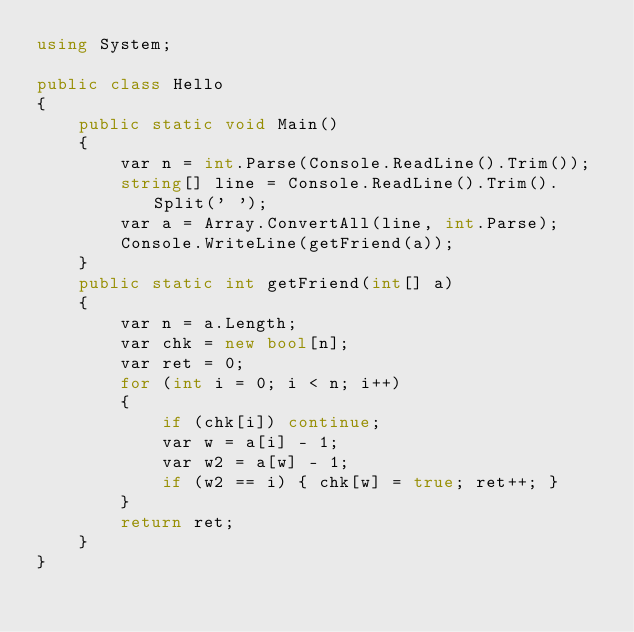Convert code to text. <code><loc_0><loc_0><loc_500><loc_500><_C#_>using System;

public class Hello
{
    public static void Main()
    {
        var n = int.Parse(Console.ReadLine().Trim());
        string[] line = Console.ReadLine().Trim().Split(' ');
        var a = Array.ConvertAll(line, int.Parse);
        Console.WriteLine(getFriend(a));
    }
    public static int getFriend(int[] a)
    {
        var n = a.Length;
        var chk = new bool[n];
        var ret = 0;
        for (int i = 0; i < n; i++)
        {
            if (chk[i]) continue;
            var w = a[i] - 1;
            var w2 = a[w] - 1;
            if (w2 == i) { chk[w] = true; ret++; }
        }
        return ret;
    }
}</code> 